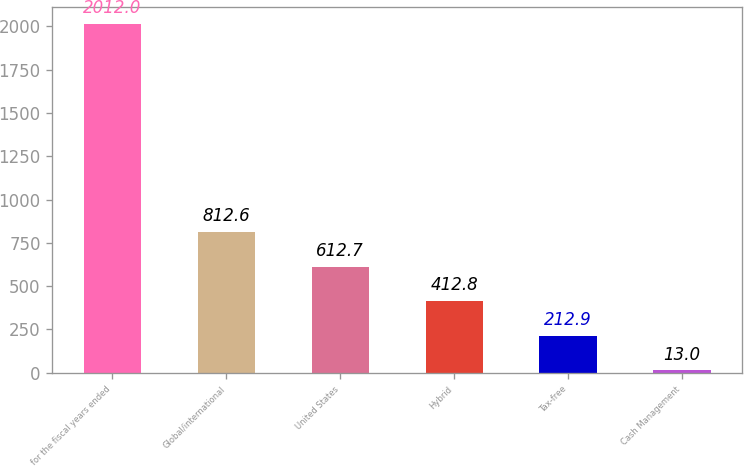<chart> <loc_0><loc_0><loc_500><loc_500><bar_chart><fcel>for the fiscal years ended<fcel>Global/international<fcel>United States<fcel>Hybrid<fcel>Tax-free<fcel>Cash Management<nl><fcel>2012<fcel>812.6<fcel>612.7<fcel>412.8<fcel>212.9<fcel>13<nl></chart> 